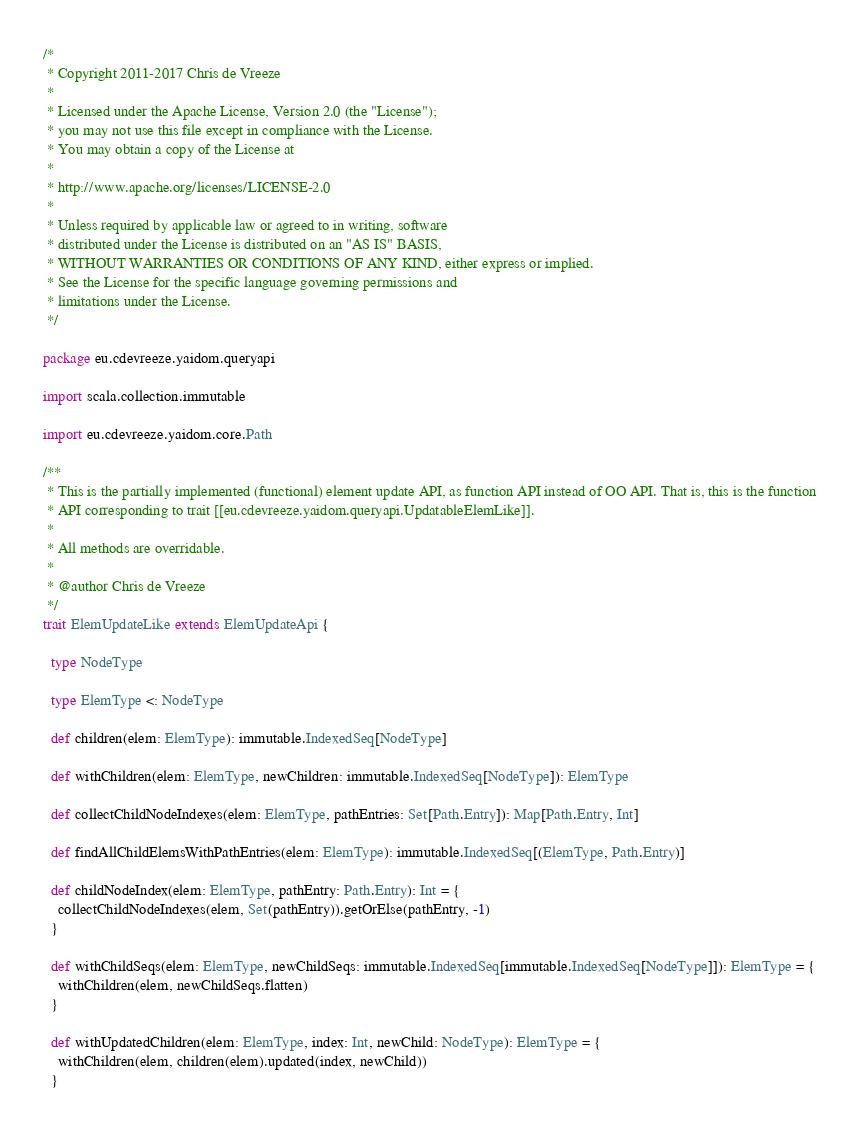<code> <loc_0><loc_0><loc_500><loc_500><_Scala_>/*
 * Copyright 2011-2017 Chris de Vreeze
 *
 * Licensed under the Apache License, Version 2.0 (the "License");
 * you may not use this file except in compliance with the License.
 * You may obtain a copy of the License at
 *
 * http://www.apache.org/licenses/LICENSE-2.0
 *
 * Unless required by applicable law or agreed to in writing, software
 * distributed under the License is distributed on an "AS IS" BASIS,
 * WITHOUT WARRANTIES OR CONDITIONS OF ANY KIND, either express or implied.
 * See the License for the specific language governing permissions and
 * limitations under the License.
 */

package eu.cdevreeze.yaidom.queryapi

import scala.collection.immutable

import eu.cdevreeze.yaidom.core.Path

/**
 * This is the partially implemented (functional) element update API, as function API instead of OO API. That is, this is the function
 * API corresponding to trait [[eu.cdevreeze.yaidom.queryapi.UpdatableElemLike]].
 *
 * All methods are overridable.
 *
 * @author Chris de Vreeze
 */
trait ElemUpdateLike extends ElemUpdateApi {

  type NodeType

  type ElemType <: NodeType

  def children(elem: ElemType): immutable.IndexedSeq[NodeType]

  def withChildren(elem: ElemType, newChildren: immutable.IndexedSeq[NodeType]): ElemType

  def collectChildNodeIndexes(elem: ElemType, pathEntries: Set[Path.Entry]): Map[Path.Entry, Int]

  def findAllChildElemsWithPathEntries(elem: ElemType): immutable.IndexedSeq[(ElemType, Path.Entry)]

  def childNodeIndex(elem: ElemType, pathEntry: Path.Entry): Int = {
    collectChildNodeIndexes(elem, Set(pathEntry)).getOrElse(pathEntry, -1)
  }

  def withChildSeqs(elem: ElemType, newChildSeqs: immutable.IndexedSeq[immutable.IndexedSeq[NodeType]]): ElemType = {
    withChildren(elem, newChildSeqs.flatten)
  }

  def withUpdatedChildren(elem: ElemType, index: Int, newChild: NodeType): ElemType = {
    withChildren(elem, children(elem).updated(index, newChild))
  }
</code> 